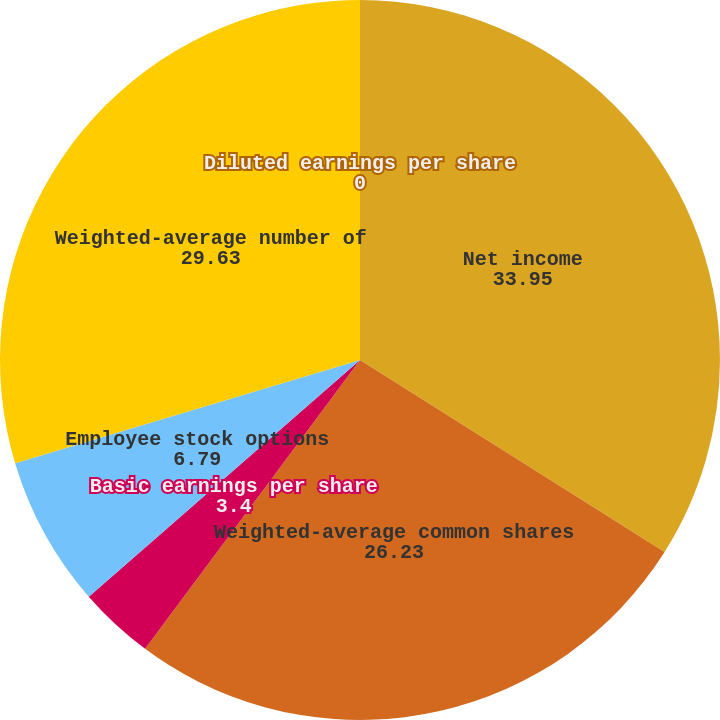<chart> <loc_0><loc_0><loc_500><loc_500><pie_chart><fcel>Net income<fcel>Weighted-average common shares<fcel>Basic earnings per share<fcel>Employee stock options<fcel>Weighted-average number of<fcel>Diluted earnings per share<nl><fcel>33.95%<fcel>26.23%<fcel>3.4%<fcel>6.79%<fcel>29.63%<fcel>0.0%<nl></chart> 